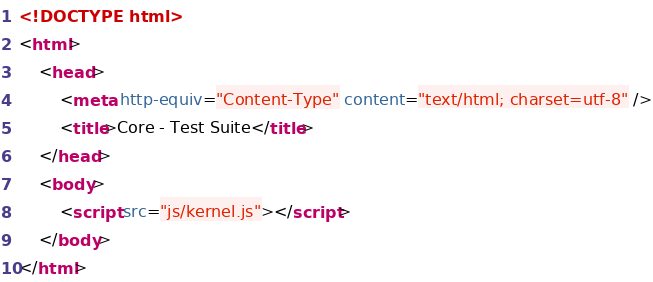Convert code to text. <code><loc_0><loc_0><loc_500><loc_500><_HTML_><!DOCTYPE html>
<html>
	<head>
		<meta http-equiv="Content-Type" content="text/html; charset=utf-8" />
		<title>Core - Test Suite</title>
	</head>
	<body>
		<script src="js/kernel.js"></script>
	</body>
</html>
</code> 